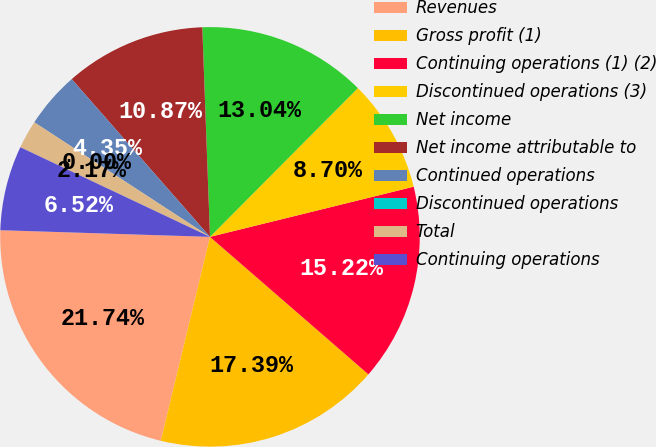<chart> <loc_0><loc_0><loc_500><loc_500><pie_chart><fcel>Revenues<fcel>Gross profit (1)<fcel>Continuing operations (1) (2)<fcel>Discontinued operations (3)<fcel>Net income<fcel>Net income attributable to<fcel>Continued operations<fcel>Discontinued operations<fcel>Total<fcel>Continuing operations<nl><fcel>21.74%<fcel>17.39%<fcel>15.22%<fcel>8.7%<fcel>13.04%<fcel>10.87%<fcel>4.35%<fcel>0.0%<fcel>2.17%<fcel>6.52%<nl></chart> 